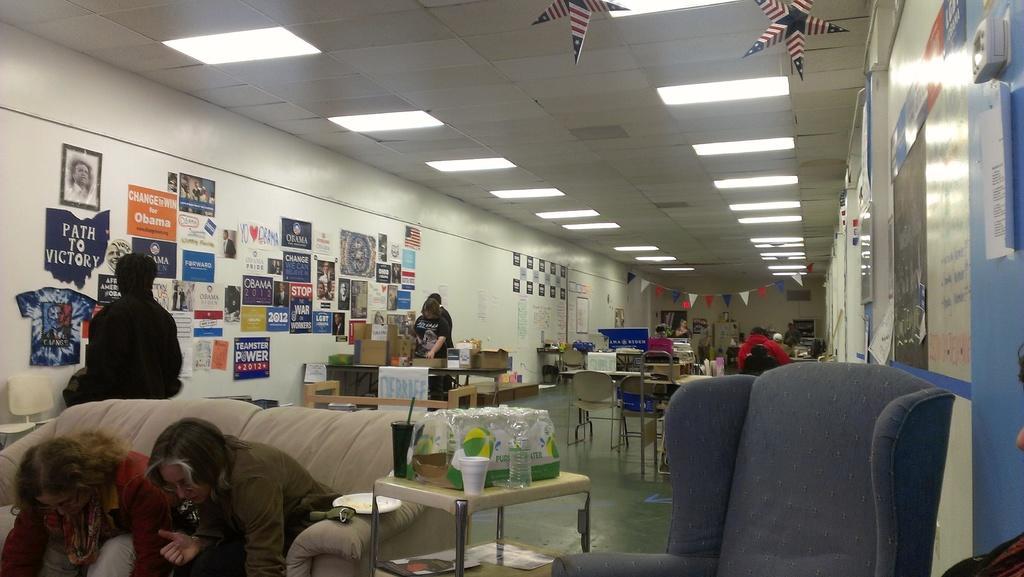Could you give a brief overview of what you see in this image? In a room there are so many chairs and tables are arranged. And a bottle on it behind that there is a table with bottles. 